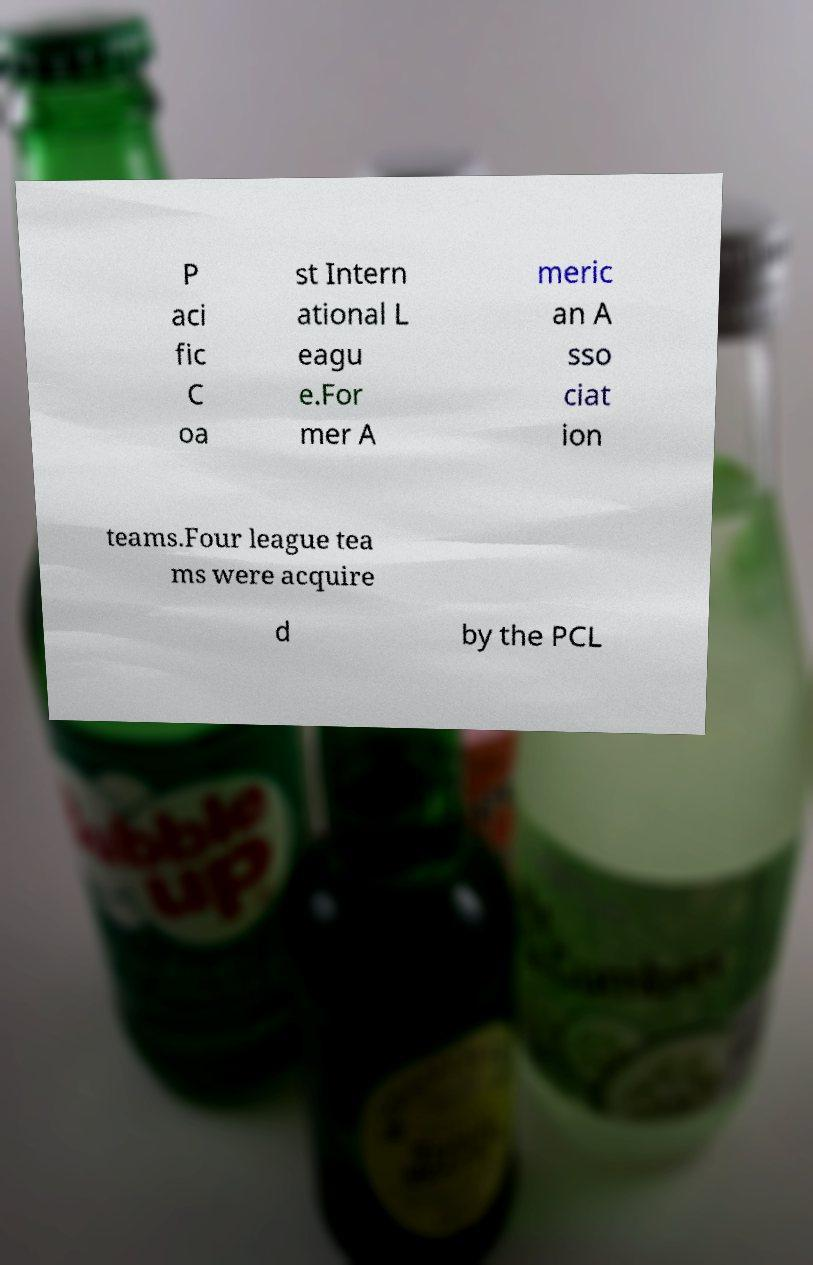Can you read and provide the text displayed in the image?This photo seems to have some interesting text. Can you extract and type it out for me? P aci fic C oa st Intern ational L eagu e.For mer A meric an A sso ciat ion teams.Four league tea ms were acquire d by the PCL 